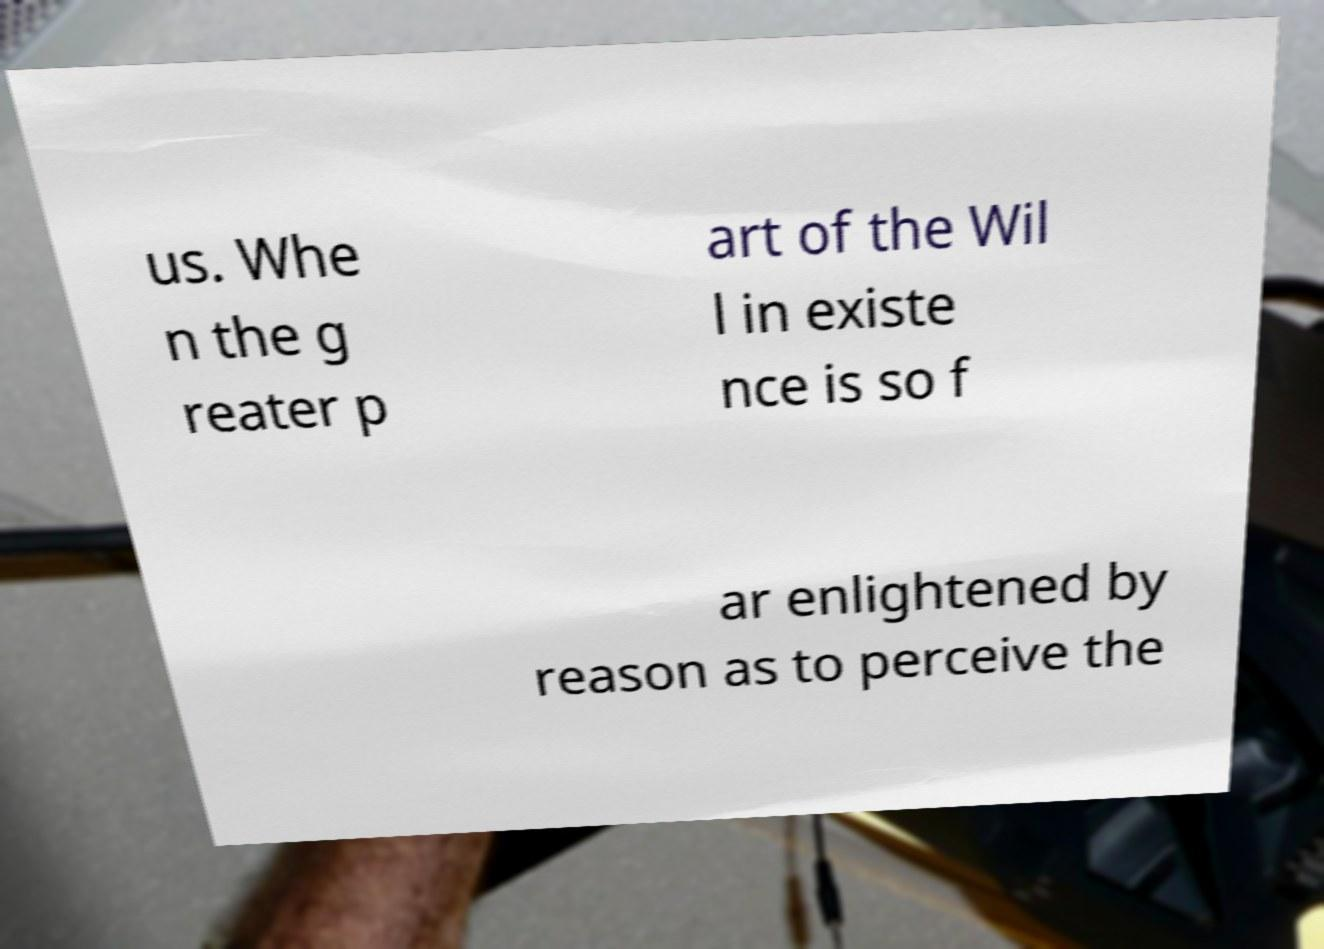Please identify and transcribe the text found in this image. us. Whe n the g reater p art of the Wil l in existe nce is so f ar enlightened by reason as to perceive the 